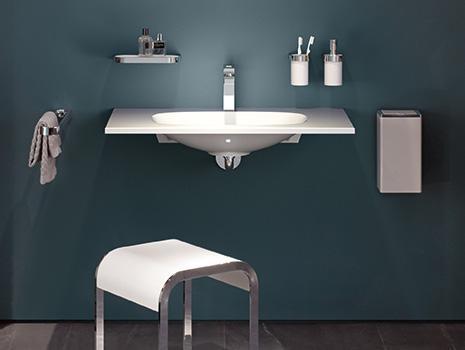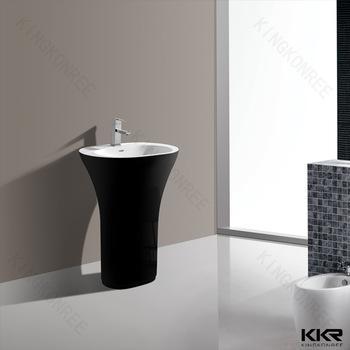The first image is the image on the left, the second image is the image on the right. Examine the images to the left and right. Is the description "In one image, a wall-mounted bathroom sink with underside visible is shown with a wall mounted mirror, shaving mirror, and two toothbrush holders." accurate? Answer yes or no. No. The first image is the image on the left, the second image is the image on the right. Considering the images on both sides, is "One image includes a small round vanity mirror projecting from the wall next to a larger mirror above an oblong sink inset in a narrow, plank-like counter." valid? Answer yes or no. No. 